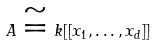Convert formula to latex. <formula><loc_0><loc_0><loc_500><loc_500>A \cong k [ [ x _ { 1 } , \dots , x _ { d } ] ]</formula> 